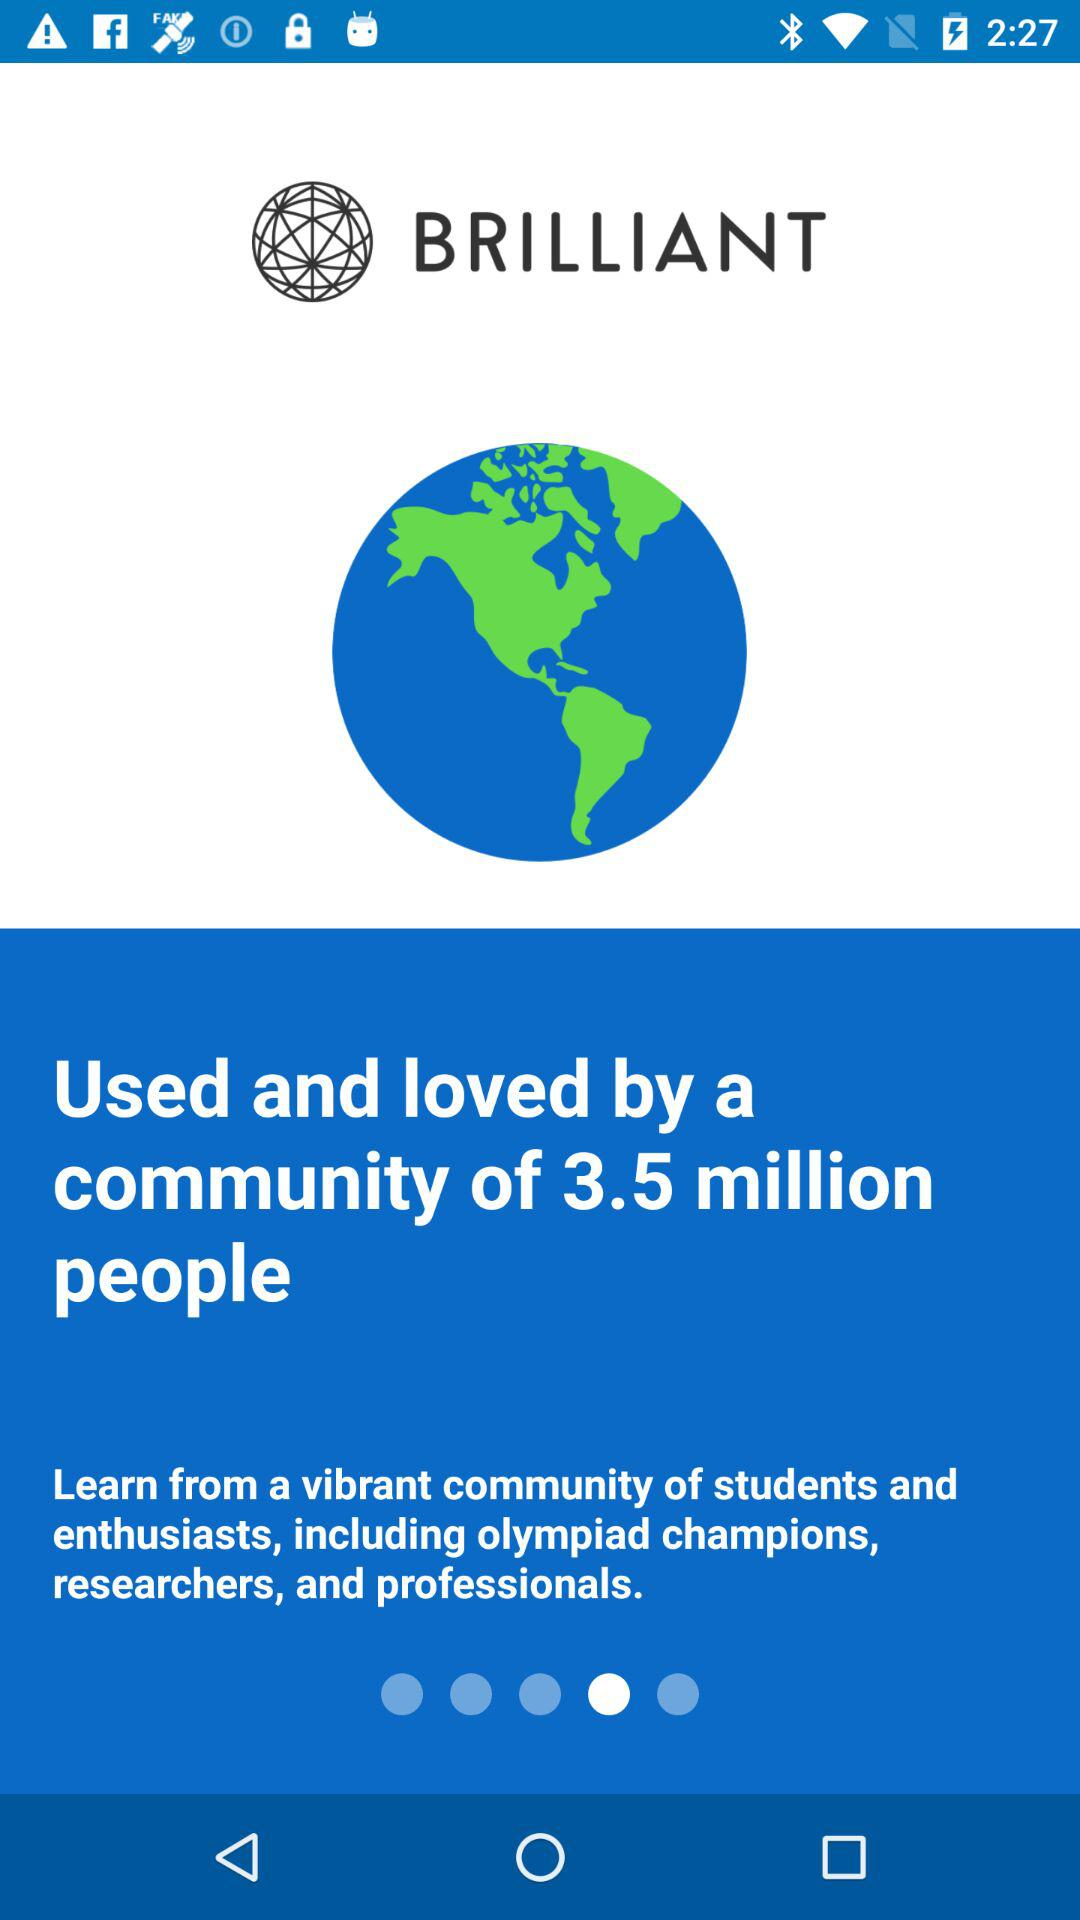What is the name of the application? The name of the application is "BRILLIANT". 